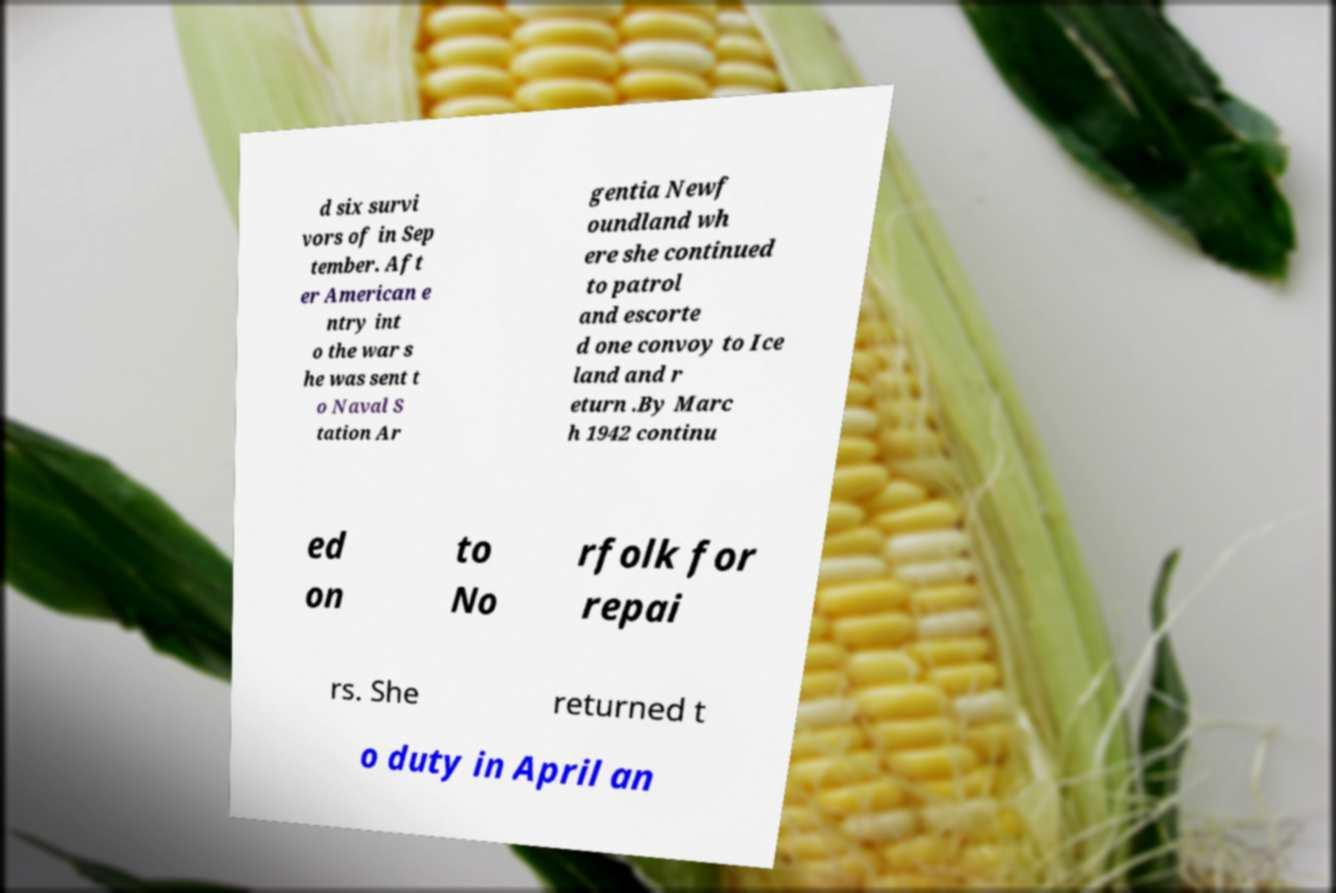I need the written content from this picture converted into text. Can you do that? d six survi vors of in Sep tember. Aft er American e ntry int o the war s he was sent t o Naval S tation Ar gentia Newf oundland wh ere she continued to patrol and escorte d one convoy to Ice land and r eturn .By Marc h 1942 continu ed on to No rfolk for repai rs. She returned t o duty in April an 